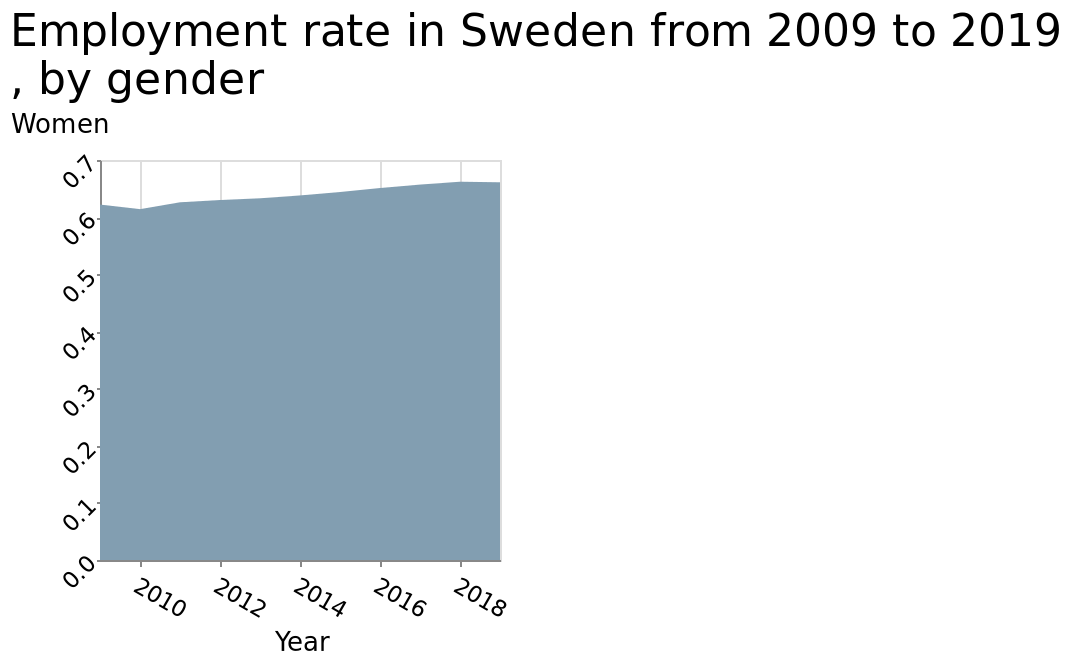<image>
please summary the statistics and relations of the chart The chart shows an increase in the employment rate of women in Sweden in the years between 2009 and 2019, from just over 0.6 to nearly 0.7. What is the employment rate of women in Sweden in 2019?  The employment rate of women in Sweden in 2019 was nearly 0.7. By how much did the employment rate of women in Sweden increase between 2009 and 2019? The employment rate of women in Sweden increased by approximately 0.1 between 2009 and 2019. 